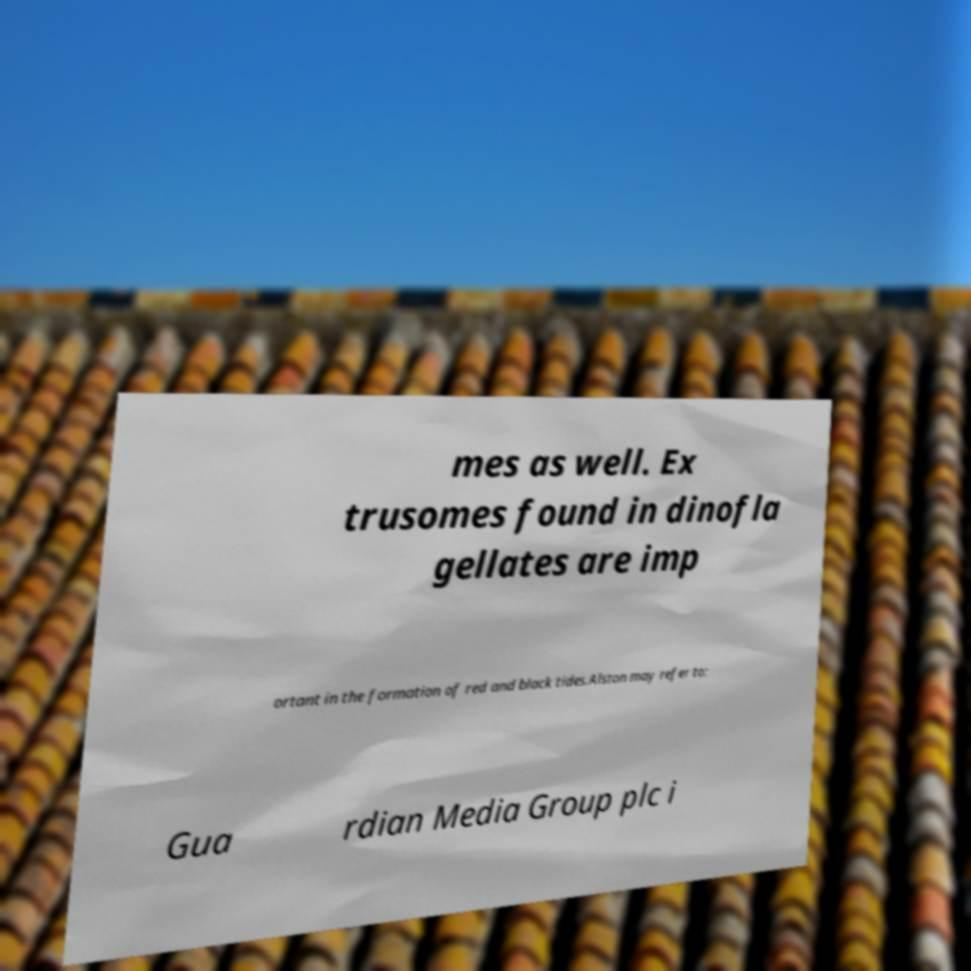For documentation purposes, I need the text within this image transcribed. Could you provide that? mes as well. Ex trusomes found in dinofla gellates are imp ortant in the formation of red and black tides.Alston may refer to: Gua rdian Media Group plc i 